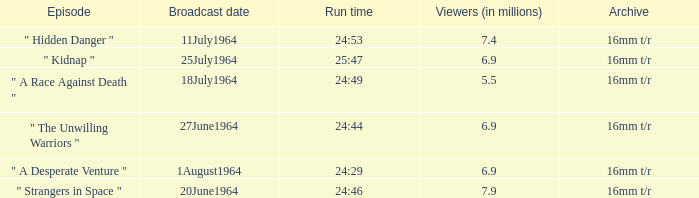What episode aired on 11july1964? " Hidden Danger ". 